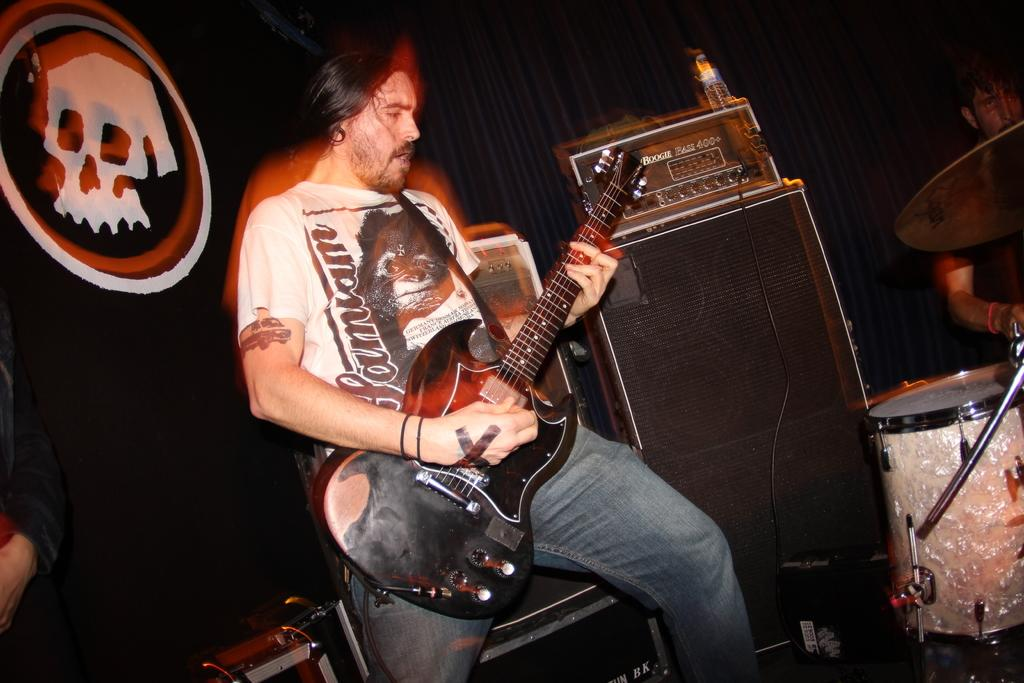What is the man in the image doing? The man in the image is playing a guitar. What can be seen in the background of the image? There is an electronic device, speakers, a drum, and a cymbal visible in the background. Can you describe the partial part of a man visible in the background? A partial part of a man is visible in the background, but no specific details can be discerned. Is there any blood visible on the guitar in the image? No, there is no blood visible on the guitar in the image. What type of ball is being used by the man playing the guitar in the image? There is no ball present in the image; the man is playing a guitar. 